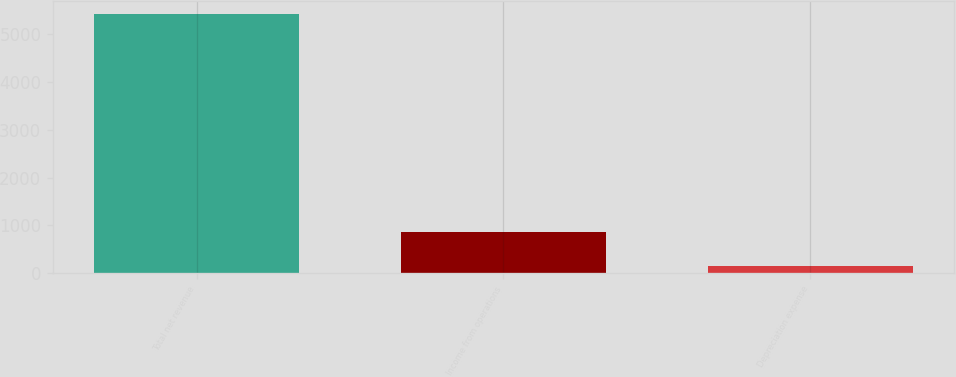<chart> <loc_0><loc_0><loc_500><loc_500><bar_chart><fcel>Total net revenue<fcel>Income from operations<fcel>Depreciation expense<nl><fcel>5420<fcel>858<fcel>142<nl></chart> 